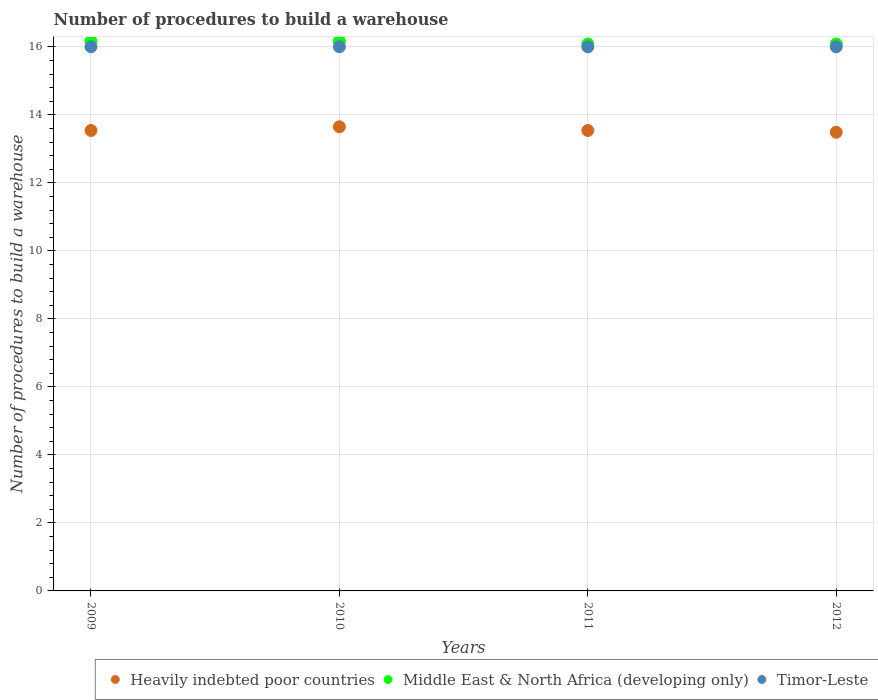Is the number of dotlines equal to the number of legend labels?
Make the answer very short. Yes. What is the number of procedures to build a warehouse in in Middle East & North Africa (developing only) in 2012?
Keep it short and to the point. 16.08. Across all years, what is the maximum number of procedures to build a warehouse in in Middle East & North Africa (developing only)?
Provide a short and direct response. 16.17. Across all years, what is the minimum number of procedures to build a warehouse in in Heavily indebted poor countries?
Provide a succinct answer. 13.49. In which year was the number of procedures to build a warehouse in in Middle East & North Africa (developing only) maximum?
Your response must be concise. 2009. In which year was the number of procedures to build a warehouse in in Timor-Leste minimum?
Your answer should be very brief. 2009. What is the total number of procedures to build a warehouse in in Heavily indebted poor countries in the graph?
Give a very brief answer. 54.22. What is the difference between the number of procedures to build a warehouse in in Heavily indebted poor countries in 2011 and that in 2012?
Your response must be concise. 0.05. What is the difference between the number of procedures to build a warehouse in in Timor-Leste in 2011 and the number of procedures to build a warehouse in in Heavily indebted poor countries in 2012?
Give a very brief answer. 2.51. What is the average number of procedures to build a warehouse in in Middle East & North Africa (developing only) per year?
Provide a succinct answer. 16.12. In the year 2009, what is the difference between the number of procedures to build a warehouse in in Heavily indebted poor countries and number of procedures to build a warehouse in in Timor-Leste?
Your answer should be very brief. -2.46. What is the ratio of the number of procedures to build a warehouse in in Timor-Leste in 2010 to that in 2012?
Make the answer very short. 1. Is the number of procedures to build a warehouse in in Heavily indebted poor countries in 2009 less than that in 2012?
Your answer should be very brief. No. What is the difference between the highest and the lowest number of procedures to build a warehouse in in Heavily indebted poor countries?
Your answer should be very brief. 0.16. In how many years, is the number of procedures to build a warehouse in in Timor-Leste greater than the average number of procedures to build a warehouse in in Timor-Leste taken over all years?
Your answer should be very brief. 0. Is the sum of the number of procedures to build a warehouse in in Timor-Leste in 2011 and 2012 greater than the maximum number of procedures to build a warehouse in in Middle East & North Africa (developing only) across all years?
Make the answer very short. Yes. Is it the case that in every year, the sum of the number of procedures to build a warehouse in in Heavily indebted poor countries and number of procedures to build a warehouse in in Timor-Leste  is greater than the number of procedures to build a warehouse in in Middle East & North Africa (developing only)?
Provide a succinct answer. Yes. Does the number of procedures to build a warehouse in in Middle East & North Africa (developing only) monotonically increase over the years?
Make the answer very short. No. Is the number of procedures to build a warehouse in in Heavily indebted poor countries strictly greater than the number of procedures to build a warehouse in in Timor-Leste over the years?
Ensure brevity in your answer.  No. How many dotlines are there?
Your answer should be very brief. 3. How many years are there in the graph?
Offer a very short reply. 4. What is the difference between two consecutive major ticks on the Y-axis?
Your response must be concise. 2. Are the values on the major ticks of Y-axis written in scientific E-notation?
Provide a short and direct response. No. What is the title of the graph?
Your response must be concise. Number of procedures to build a warehouse. Does "Burkina Faso" appear as one of the legend labels in the graph?
Ensure brevity in your answer.  No. What is the label or title of the X-axis?
Ensure brevity in your answer.  Years. What is the label or title of the Y-axis?
Offer a terse response. Number of procedures to build a warehouse. What is the Number of procedures to build a warehouse of Heavily indebted poor countries in 2009?
Provide a short and direct response. 13.54. What is the Number of procedures to build a warehouse of Middle East & North Africa (developing only) in 2009?
Your response must be concise. 16.17. What is the Number of procedures to build a warehouse in Heavily indebted poor countries in 2010?
Provide a succinct answer. 13.65. What is the Number of procedures to build a warehouse of Middle East & North Africa (developing only) in 2010?
Your response must be concise. 16.17. What is the Number of procedures to build a warehouse in Heavily indebted poor countries in 2011?
Ensure brevity in your answer.  13.54. What is the Number of procedures to build a warehouse of Middle East & North Africa (developing only) in 2011?
Provide a succinct answer. 16.08. What is the Number of procedures to build a warehouse of Heavily indebted poor countries in 2012?
Provide a short and direct response. 13.49. What is the Number of procedures to build a warehouse in Middle East & North Africa (developing only) in 2012?
Offer a very short reply. 16.08. Across all years, what is the maximum Number of procedures to build a warehouse of Heavily indebted poor countries?
Provide a succinct answer. 13.65. Across all years, what is the maximum Number of procedures to build a warehouse in Middle East & North Africa (developing only)?
Your response must be concise. 16.17. Across all years, what is the minimum Number of procedures to build a warehouse of Heavily indebted poor countries?
Your response must be concise. 13.49. Across all years, what is the minimum Number of procedures to build a warehouse in Middle East & North Africa (developing only)?
Make the answer very short. 16.08. What is the total Number of procedures to build a warehouse in Heavily indebted poor countries in the graph?
Provide a short and direct response. 54.22. What is the total Number of procedures to build a warehouse of Middle East & North Africa (developing only) in the graph?
Provide a short and direct response. 64.5. What is the total Number of procedures to build a warehouse in Timor-Leste in the graph?
Your response must be concise. 64. What is the difference between the Number of procedures to build a warehouse of Heavily indebted poor countries in 2009 and that in 2010?
Your answer should be compact. -0.11. What is the difference between the Number of procedures to build a warehouse in Middle East & North Africa (developing only) in 2009 and that in 2010?
Your response must be concise. 0. What is the difference between the Number of procedures to build a warehouse in Timor-Leste in 2009 and that in 2010?
Ensure brevity in your answer.  0. What is the difference between the Number of procedures to build a warehouse of Heavily indebted poor countries in 2009 and that in 2011?
Offer a very short reply. 0. What is the difference between the Number of procedures to build a warehouse in Middle East & North Africa (developing only) in 2009 and that in 2011?
Provide a succinct answer. 0.08. What is the difference between the Number of procedures to build a warehouse of Timor-Leste in 2009 and that in 2011?
Your answer should be very brief. 0. What is the difference between the Number of procedures to build a warehouse in Heavily indebted poor countries in 2009 and that in 2012?
Make the answer very short. 0.05. What is the difference between the Number of procedures to build a warehouse in Middle East & North Africa (developing only) in 2009 and that in 2012?
Make the answer very short. 0.08. What is the difference between the Number of procedures to build a warehouse in Heavily indebted poor countries in 2010 and that in 2011?
Your answer should be very brief. 0.11. What is the difference between the Number of procedures to build a warehouse of Middle East & North Africa (developing only) in 2010 and that in 2011?
Provide a short and direct response. 0.08. What is the difference between the Number of procedures to build a warehouse in Heavily indebted poor countries in 2010 and that in 2012?
Offer a very short reply. 0.16. What is the difference between the Number of procedures to build a warehouse in Middle East & North Africa (developing only) in 2010 and that in 2012?
Your answer should be compact. 0.08. What is the difference between the Number of procedures to build a warehouse in Timor-Leste in 2010 and that in 2012?
Keep it short and to the point. 0. What is the difference between the Number of procedures to build a warehouse in Heavily indebted poor countries in 2011 and that in 2012?
Keep it short and to the point. 0.05. What is the difference between the Number of procedures to build a warehouse of Timor-Leste in 2011 and that in 2012?
Provide a succinct answer. 0. What is the difference between the Number of procedures to build a warehouse in Heavily indebted poor countries in 2009 and the Number of procedures to build a warehouse in Middle East & North Africa (developing only) in 2010?
Give a very brief answer. -2.63. What is the difference between the Number of procedures to build a warehouse of Heavily indebted poor countries in 2009 and the Number of procedures to build a warehouse of Timor-Leste in 2010?
Your answer should be compact. -2.46. What is the difference between the Number of procedures to build a warehouse in Heavily indebted poor countries in 2009 and the Number of procedures to build a warehouse in Middle East & North Africa (developing only) in 2011?
Provide a succinct answer. -2.54. What is the difference between the Number of procedures to build a warehouse of Heavily indebted poor countries in 2009 and the Number of procedures to build a warehouse of Timor-Leste in 2011?
Your answer should be compact. -2.46. What is the difference between the Number of procedures to build a warehouse of Middle East & North Africa (developing only) in 2009 and the Number of procedures to build a warehouse of Timor-Leste in 2011?
Ensure brevity in your answer.  0.17. What is the difference between the Number of procedures to build a warehouse in Heavily indebted poor countries in 2009 and the Number of procedures to build a warehouse in Middle East & North Africa (developing only) in 2012?
Make the answer very short. -2.54. What is the difference between the Number of procedures to build a warehouse in Heavily indebted poor countries in 2009 and the Number of procedures to build a warehouse in Timor-Leste in 2012?
Your response must be concise. -2.46. What is the difference between the Number of procedures to build a warehouse of Middle East & North Africa (developing only) in 2009 and the Number of procedures to build a warehouse of Timor-Leste in 2012?
Your response must be concise. 0.17. What is the difference between the Number of procedures to build a warehouse in Heavily indebted poor countries in 2010 and the Number of procedures to build a warehouse in Middle East & North Africa (developing only) in 2011?
Provide a short and direct response. -2.43. What is the difference between the Number of procedures to build a warehouse of Heavily indebted poor countries in 2010 and the Number of procedures to build a warehouse of Timor-Leste in 2011?
Offer a terse response. -2.35. What is the difference between the Number of procedures to build a warehouse in Heavily indebted poor countries in 2010 and the Number of procedures to build a warehouse in Middle East & North Africa (developing only) in 2012?
Offer a very short reply. -2.43. What is the difference between the Number of procedures to build a warehouse in Heavily indebted poor countries in 2010 and the Number of procedures to build a warehouse in Timor-Leste in 2012?
Provide a short and direct response. -2.35. What is the difference between the Number of procedures to build a warehouse in Heavily indebted poor countries in 2011 and the Number of procedures to build a warehouse in Middle East & North Africa (developing only) in 2012?
Your answer should be compact. -2.54. What is the difference between the Number of procedures to build a warehouse in Heavily indebted poor countries in 2011 and the Number of procedures to build a warehouse in Timor-Leste in 2012?
Make the answer very short. -2.46. What is the difference between the Number of procedures to build a warehouse of Middle East & North Africa (developing only) in 2011 and the Number of procedures to build a warehouse of Timor-Leste in 2012?
Provide a succinct answer. 0.08. What is the average Number of procedures to build a warehouse in Heavily indebted poor countries per year?
Make the answer very short. 13.55. What is the average Number of procedures to build a warehouse of Middle East & North Africa (developing only) per year?
Ensure brevity in your answer.  16.12. In the year 2009, what is the difference between the Number of procedures to build a warehouse in Heavily indebted poor countries and Number of procedures to build a warehouse in Middle East & North Africa (developing only)?
Your answer should be very brief. -2.63. In the year 2009, what is the difference between the Number of procedures to build a warehouse of Heavily indebted poor countries and Number of procedures to build a warehouse of Timor-Leste?
Provide a short and direct response. -2.46. In the year 2009, what is the difference between the Number of procedures to build a warehouse in Middle East & North Africa (developing only) and Number of procedures to build a warehouse in Timor-Leste?
Provide a short and direct response. 0.17. In the year 2010, what is the difference between the Number of procedures to build a warehouse of Heavily indebted poor countries and Number of procedures to build a warehouse of Middle East & North Africa (developing only)?
Ensure brevity in your answer.  -2.52. In the year 2010, what is the difference between the Number of procedures to build a warehouse in Heavily indebted poor countries and Number of procedures to build a warehouse in Timor-Leste?
Give a very brief answer. -2.35. In the year 2010, what is the difference between the Number of procedures to build a warehouse in Middle East & North Africa (developing only) and Number of procedures to build a warehouse in Timor-Leste?
Provide a succinct answer. 0.17. In the year 2011, what is the difference between the Number of procedures to build a warehouse of Heavily indebted poor countries and Number of procedures to build a warehouse of Middle East & North Africa (developing only)?
Ensure brevity in your answer.  -2.54. In the year 2011, what is the difference between the Number of procedures to build a warehouse in Heavily indebted poor countries and Number of procedures to build a warehouse in Timor-Leste?
Make the answer very short. -2.46. In the year 2011, what is the difference between the Number of procedures to build a warehouse of Middle East & North Africa (developing only) and Number of procedures to build a warehouse of Timor-Leste?
Your response must be concise. 0.08. In the year 2012, what is the difference between the Number of procedures to build a warehouse in Heavily indebted poor countries and Number of procedures to build a warehouse in Middle East & North Africa (developing only)?
Offer a very short reply. -2.6. In the year 2012, what is the difference between the Number of procedures to build a warehouse in Heavily indebted poor countries and Number of procedures to build a warehouse in Timor-Leste?
Provide a short and direct response. -2.51. In the year 2012, what is the difference between the Number of procedures to build a warehouse in Middle East & North Africa (developing only) and Number of procedures to build a warehouse in Timor-Leste?
Your answer should be compact. 0.08. What is the ratio of the Number of procedures to build a warehouse in Heavily indebted poor countries in 2009 to that in 2010?
Keep it short and to the point. 0.99. What is the ratio of the Number of procedures to build a warehouse of Middle East & North Africa (developing only) in 2009 to that in 2010?
Your answer should be compact. 1. What is the ratio of the Number of procedures to build a warehouse of Heavily indebted poor countries in 2009 to that in 2012?
Your answer should be compact. 1. What is the ratio of the Number of procedures to build a warehouse in Heavily indebted poor countries in 2010 to that in 2011?
Make the answer very short. 1.01. What is the ratio of the Number of procedures to build a warehouse in Timor-Leste in 2010 to that in 2011?
Your response must be concise. 1. What is the difference between the highest and the second highest Number of procedures to build a warehouse of Heavily indebted poor countries?
Ensure brevity in your answer.  0.11. What is the difference between the highest and the second highest Number of procedures to build a warehouse of Middle East & North Africa (developing only)?
Ensure brevity in your answer.  0. What is the difference between the highest and the second highest Number of procedures to build a warehouse in Timor-Leste?
Offer a terse response. 0. What is the difference between the highest and the lowest Number of procedures to build a warehouse in Heavily indebted poor countries?
Make the answer very short. 0.16. What is the difference between the highest and the lowest Number of procedures to build a warehouse of Middle East & North Africa (developing only)?
Make the answer very short. 0.08. What is the difference between the highest and the lowest Number of procedures to build a warehouse in Timor-Leste?
Provide a short and direct response. 0. 